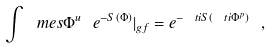Convert formula to latex. <formula><loc_0><loc_0><loc_500><loc_500>\int \ m e s \Phi ^ { u } \ e ^ { - S ( \Phi ) } | _ { g f } = e ^ { - \ t i { S } ( \ t i \Phi ^ { p } ) } \ ,</formula> 